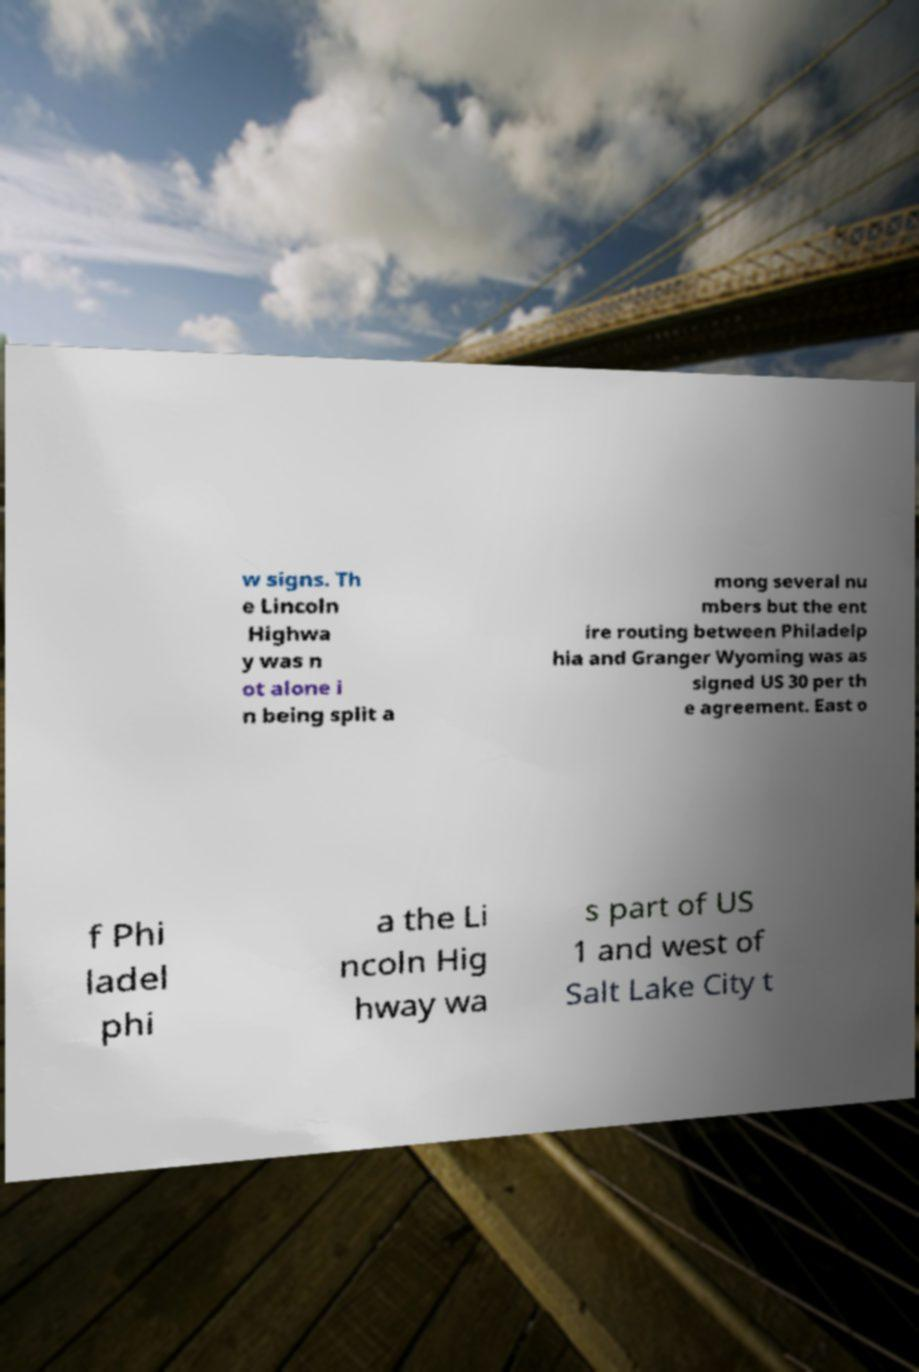Please read and relay the text visible in this image. What does it say? w signs. Th e Lincoln Highwa y was n ot alone i n being split a mong several nu mbers but the ent ire routing between Philadelp hia and Granger Wyoming was as signed US 30 per th e agreement. East o f Phi ladel phi a the Li ncoln Hig hway wa s part of US 1 and west of Salt Lake City t 